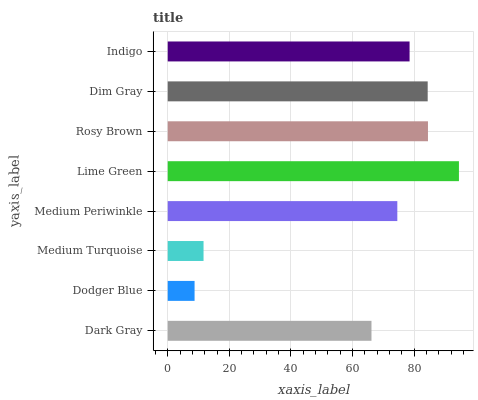Is Dodger Blue the minimum?
Answer yes or no. Yes. Is Lime Green the maximum?
Answer yes or no. Yes. Is Medium Turquoise the minimum?
Answer yes or no. No. Is Medium Turquoise the maximum?
Answer yes or no. No. Is Medium Turquoise greater than Dodger Blue?
Answer yes or no. Yes. Is Dodger Blue less than Medium Turquoise?
Answer yes or no. Yes. Is Dodger Blue greater than Medium Turquoise?
Answer yes or no. No. Is Medium Turquoise less than Dodger Blue?
Answer yes or no. No. Is Indigo the high median?
Answer yes or no. Yes. Is Medium Periwinkle the low median?
Answer yes or no. Yes. Is Dodger Blue the high median?
Answer yes or no. No. Is Rosy Brown the low median?
Answer yes or no. No. 